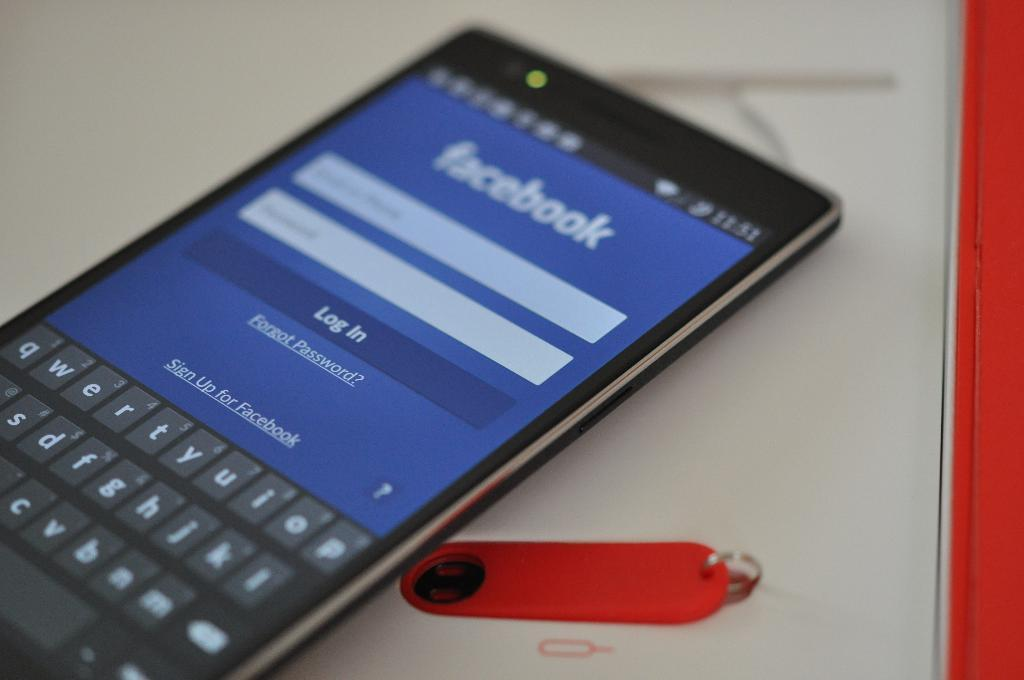<image>
Offer a succinct explanation of the picture presented. The log in screen for Facebook on a smartphone. 